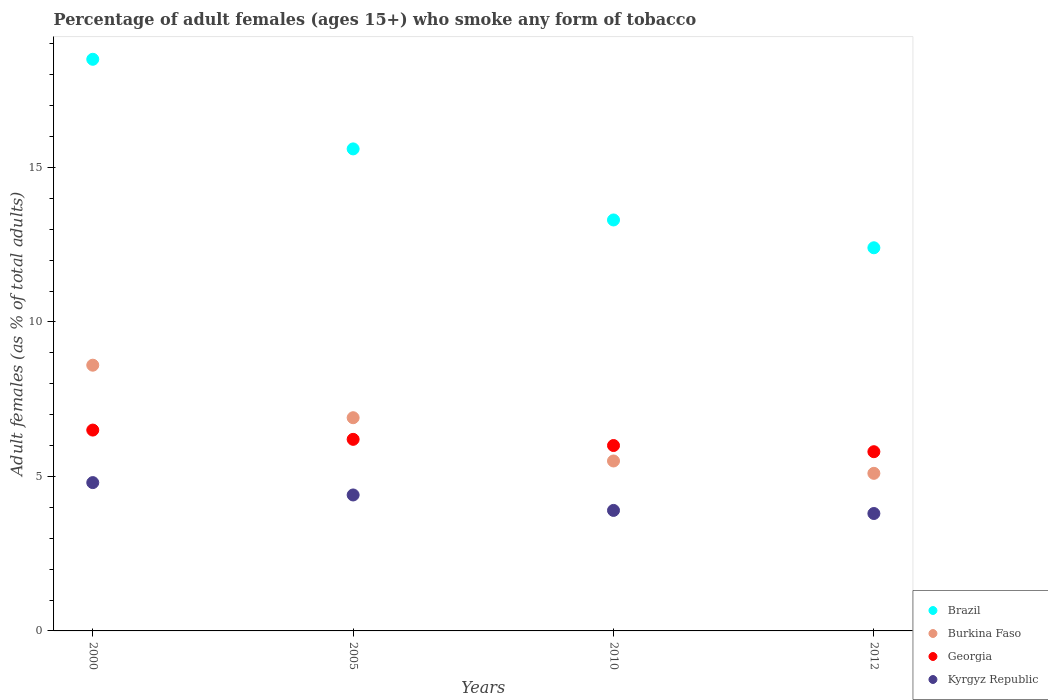Across all years, what is the maximum percentage of adult females who smoke in Kyrgyz Republic?
Make the answer very short. 4.8. Across all years, what is the minimum percentage of adult females who smoke in Georgia?
Your response must be concise. 5.8. In which year was the percentage of adult females who smoke in Kyrgyz Republic maximum?
Your answer should be compact. 2000. What is the total percentage of adult females who smoke in Burkina Faso in the graph?
Your response must be concise. 26.1. What is the difference between the percentage of adult females who smoke in Burkina Faso in 2000 and that in 2012?
Keep it short and to the point. 3.5. What is the difference between the percentage of adult females who smoke in Burkina Faso in 2005 and the percentage of adult females who smoke in Brazil in 2010?
Make the answer very short. -6.4. What is the average percentage of adult females who smoke in Brazil per year?
Provide a succinct answer. 14.95. In the year 2005, what is the difference between the percentage of adult females who smoke in Georgia and percentage of adult females who smoke in Brazil?
Give a very brief answer. -9.4. What is the ratio of the percentage of adult females who smoke in Kyrgyz Republic in 2005 to that in 2010?
Your answer should be very brief. 1.13. Is the difference between the percentage of adult females who smoke in Georgia in 2005 and 2010 greater than the difference between the percentage of adult females who smoke in Brazil in 2005 and 2010?
Provide a short and direct response. No. What is the difference between the highest and the second highest percentage of adult females who smoke in Burkina Faso?
Offer a terse response. 1.7. Is it the case that in every year, the sum of the percentage of adult females who smoke in Kyrgyz Republic and percentage of adult females who smoke in Brazil  is greater than the percentage of adult females who smoke in Burkina Faso?
Offer a terse response. Yes. Does the percentage of adult females who smoke in Brazil monotonically increase over the years?
Provide a short and direct response. No. Is the percentage of adult females who smoke in Brazil strictly less than the percentage of adult females who smoke in Kyrgyz Republic over the years?
Give a very brief answer. No. What is the difference between two consecutive major ticks on the Y-axis?
Make the answer very short. 5. Does the graph contain grids?
Ensure brevity in your answer.  No. Where does the legend appear in the graph?
Your answer should be compact. Bottom right. How many legend labels are there?
Your response must be concise. 4. How are the legend labels stacked?
Give a very brief answer. Vertical. What is the title of the graph?
Your answer should be very brief. Percentage of adult females (ages 15+) who smoke any form of tobacco. What is the label or title of the Y-axis?
Offer a very short reply. Adult females (as % of total adults). What is the Adult females (as % of total adults) in Brazil in 2000?
Make the answer very short. 18.5. What is the Adult females (as % of total adults) of Georgia in 2000?
Keep it short and to the point. 6.5. What is the Adult females (as % of total adults) of Kyrgyz Republic in 2000?
Keep it short and to the point. 4.8. What is the Adult females (as % of total adults) in Burkina Faso in 2005?
Your answer should be compact. 6.9. What is the Adult females (as % of total adults) of Georgia in 2012?
Make the answer very short. 5.8. Across all years, what is the maximum Adult females (as % of total adults) of Brazil?
Keep it short and to the point. 18.5. Across all years, what is the maximum Adult females (as % of total adults) in Burkina Faso?
Offer a very short reply. 8.6. Across all years, what is the maximum Adult females (as % of total adults) in Georgia?
Make the answer very short. 6.5. Across all years, what is the maximum Adult females (as % of total adults) of Kyrgyz Republic?
Keep it short and to the point. 4.8. Across all years, what is the minimum Adult females (as % of total adults) of Burkina Faso?
Make the answer very short. 5.1. Across all years, what is the minimum Adult females (as % of total adults) in Georgia?
Provide a succinct answer. 5.8. Across all years, what is the minimum Adult females (as % of total adults) in Kyrgyz Republic?
Your answer should be compact. 3.8. What is the total Adult females (as % of total adults) of Brazil in the graph?
Ensure brevity in your answer.  59.8. What is the total Adult females (as % of total adults) of Burkina Faso in the graph?
Keep it short and to the point. 26.1. What is the difference between the Adult females (as % of total adults) of Brazil in 2000 and that in 2005?
Give a very brief answer. 2.9. What is the difference between the Adult females (as % of total adults) in Georgia in 2000 and that in 2005?
Make the answer very short. 0.3. What is the difference between the Adult females (as % of total adults) of Brazil in 2000 and that in 2010?
Provide a succinct answer. 5.2. What is the difference between the Adult females (as % of total adults) of Georgia in 2000 and that in 2010?
Your answer should be very brief. 0.5. What is the difference between the Adult females (as % of total adults) in Kyrgyz Republic in 2000 and that in 2010?
Offer a terse response. 0.9. What is the difference between the Adult females (as % of total adults) of Burkina Faso in 2000 and that in 2012?
Make the answer very short. 3.5. What is the difference between the Adult females (as % of total adults) in Kyrgyz Republic in 2000 and that in 2012?
Keep it short and to the point. 1. What is the difference between the Adult females (as % of total adults) of Brazil in 2005 and that in 2010?
Offer a very short reply. 2.3. What is the difference between the Adult females (as % of total adults) of Burkina Faso in 2005 and that in 2010?
Your response must be concise. 1.4. What is the difference between the Adult females (as % of total adults) in Kyrgyz Republic in 2005 and that in 2010?
Provide a succinct answer. 0.5. What is the difference between the Adult females (as % of total adults) of Brazil in 2005 and that in 2012?
Give a very brief answer. 3.2. What is the difference between the Adult females (as % of total adults) in Burkina Faso in 2005 and that in 2012?
Provide a succinct answer. 1.8. What is the difference between the Adult females (as % of total adults) of Kyrgyz Republic in 2005 and that in 2012?
Your answer should be compact. 0.6. What is the difference between the Adult females (as % of total adults) of Burkina Faso in 2010 and that in 2012?
Your response must be concise. 0.4. What is the difference between the Adult females (as % of total adults) of Kyrgyz Republic in 2010 and that in 2012?
Keep it short and to the point. 0.1. What is the difference between the Adult females (as % of total adults) of Brazil in 2000 and the Adult females (as % of total adults) of Kyrgyz Republic in 2005?
Your answer should be compact. 14.1. What is the difference between the Adult females (as % of total adults) of Burkina Faso in 2000 and the Adult females (as % of total adults) of Georgia in 2005?
Offer a very short reply. 2.4. What is the difference between the Adult females (as % of total adults) in Burkina Faso in 2000 and the Adult females (as % of total adults) in Kyrgyz Republic in 2005?
Give a very brief answer. 4.2. What is the difference between the Adult females (as % of total adults) in Georgia in 2000 and the Adult females (as % of total adults) in Kyrgyz Republic in 2005?
Provide a short and direct response. 2.1. What is the difference between the Adult females (as % of total adults) in Brazil in 2000 and the Adult females (as % of total adults) in Georgia in 2010?
Provide a short and direct response. 12.5. What is the difference between the Adult females (as % of total adults) of Burkina Faso in 2000 and the Adult females (as % of total adults) of Georgia in 2010?
Make the answer very short. 2.6. What is the difference between the Adult females (as % of total adults) in Brazil in 2000 and the Adult females (as % of total adults) in Georgia in 2012?
Offer a terse response. 12.7. What is the difference between the Adult females (as % of total adults) of Brazil in 2000 and the Adult females (as % of total adults) of Kyrgyz Republic in 2012?
Your answer should be very brief. 14.7. What is the difference between the Adult females (as % of total adults) of Burkina Faso in 2000 and the Adult females (as % of total adults) of Georgia in 2012?
Keep it short and to the point. 2.8. What is the difference between the Adult females (as % of total adults) in Burkina Faso in 2000 and the Adult females (as % of total adults) in Kyrgyz Republic in 2012?
Ensure brevity in your answer.  4.8. What is the difference between the Adult females (as % of total adults) in Brazil in 2005 and the Adult females (as % of total adults) in Burkina Faso in 2010?
Provide a short and direct response. 10.1. What is the difference between the Adult females (as % of total adults) in Brazil in 2005 and the Adult females (as % of total adults) in Georgia in 2010?
Provide a succinct answer. 9.6. What is the difference between the Adult females (as % of total adults) of Brazil in 2005 and the Adult females (as % of total adults) of Georgia in 2012?
Provide a short and direct response. 9.8. What is the difference between the Adult females (as % of total adults) of Brazil in 2005 and the Adult females (as % of total adults) of Kyrgyz Republic in 2012?
Your answer should be compact. 11.8. What is the difference between the Adult females (as % of total adults) of Burkina Faso in 2005 and the Adult females (as % of total adults) of Kyrgyz Republic in 2012?
Your answer should be very brief. 3.1. What is the difference between the Adult females (as % of total adults) in Georgia in 2005 and the Adult females (as % of total adults) in Kyrgyz Republic in 2012?
Give a very brief answer. 2.4. What is the difference between the Adult females (as % of total adults) in Brazil in 2010 and the Adult females (as % of total adults) in Kyrgyz Republic in 2012?
Ensure brevity in your answer.  9.5. What is the difference between the Adult females (as % of total adults) in Burkina Faso in 2010 and the Adult females (as % of total adults) in Georgia in 2012?
Offer a terse response. -0.3. What is the difference between the Adult females (as % of total adults) in Georgia in 2010 and the Adult females (as % of total adults) in Kyrgyz Republic in 2012?
Your response must be concise. 2.2. What is the average Adult females (as % of total adults) of Brazil per year?
Your answer should be compact. 14.95. What is the average Adult females (as % of total adults) in Burkina Faso per year?
Provide a succinct answer. 6.53. What is the average Adult females (as % of total adults) of Georgia per year?
Ensure brevity in your answer.  6.12. What is the average Adult females (as % of total adults) in Kyrgyz Republic per year?
Provide a succinct answer. 4.22. In the year 2000, what is the difference between the Adult females (as % of total adults) in Brazil and Adult females (as % of total adults) in Georgia?
Offer a terse response. 12. In the year 2000, what is the difference between the Adult females (as % of total adults) of Burkina Faso and Adult females (as % of total adults) of Kyrgyz Republic?
Your answer should be very brief. 3.8. In the year 2000, what is the difference between the Adult females (as % of total adults) of Georgia and Adult females (as % of total adults) of Kyrgyz Republic?
Offer a terse response. 1.7. In the year 2005, what is the difference between the Adult females (as % of total adults) in Burkina Faso and Adult females (as % of total adults) in Georgia?
Offer a very short reply. 0.7. In the year 2005, what is the difference between the Adult females (as % of total adults) in Burkina Faso and Adult females (as % of total adults) in Kyrgyz Republic?
Your answer should be very brief. 2.5. In the year 2005, what is the difference between the Adult females (as % of total adults) in Georgia and Adult females (as % of total adults) in Kyrgyz Republic?
Make the answer very short. 1.8. In the year 2010, what is the difference between the Adult females (as % of total adults) of Brazil and Adult females (as % of total adults) of Burkina Faso?
Make the answer very short. 7.8. In the year 2010, what is the difference between the Adult females (as % of total adults) of Brazil and Adult females (as % of total adults) of Georgia?
Offer a very short reply. 7.3. In the year 2010, what is the difference between the Adult females (as % of total adults) in Burkina Faso and Adult females (as % of total adults) in Georgia?
Make the answer very short. -0.5. In the year 2012, what is the difference between the Adult females (as % of total adults) of Brazil and Adult females (as % of total adults) of Burkina Faso?
Provide a succinct answer. 7.3. In the year 2012, what is the difference between the Adult females (as % of total adults) in Brazil and Adult females (as % of total adults) in Georgia?
Your answer should be very brief. 6.6. In the year 2012, what is the difference between the Adult females (as % of total adults) in Brazil and Adult females (as % of total adults) in Kyrgyz Republic?
Provide a short and direct response. 8.6. In the year 2012, what is the difference between the Adult females (as % of total adults) of Georgia and Adult females (as % of total adults) of Kyrgyz Republic?
Ensure brevity in your answer.  2. What is the ratio of the Adult females (as % of total adults) of Brazil in 2000 to that in 2005?
Offer a very short reply. 1.19. What is the ratio of the Adult females (as % of total adults) in Burkina Faso in 2000 to that in 2005?
Give a very brief answer. 1.25. What is the ratio of the Adult females (as % of total adults) of Georgia in 2000 to that in 2005?
Your response must be concise. 1.05. What is the ratio of the Adult females (as % of total adults) of Brazil in 2000 to that in 2010?
Make the answer very short. 1.39. What is the ratio of the Adult females (as % of total adults) of Burkina Faso in 2000 to that in 2010?
Ensure brevity in your answer.  1.56. What is the ratio of the Adult females (as % of total adults) in Kyrgyz Republic in 2000 to that in 2010?
Your response must be concise. 1.23. What is the ratio of the Adult females (as % of total adults) of Brazil in 2000 to that in 2012?
Provide a succinct answer. 1.49. What is the ratio of the Adult females (as % of total adults) in Burkina Faso in 2000 to that in 2012?
Provide a short and direct response. 1.69. What is the ratio of the Adult females (as % of total adults) in Georgia in 2000 to that in 2012?
Make the answer very short. 1.12. What is the ratio of the Adult females (as % of total adults) of Kyrgyz Republic in 2000 to that in 2012?
Give a very brief answer. 1.26. What is the ratio of the Adult females (as % of total adults) of Brazil in 2005 to that in 2010?
Give a very brief answer. 1.17. What is the ratio of the Adult females (as % of total adults) in Burkina Faso in 2005 to that in 2010?
Give a very brief answer. 1.25. What is the ratio of the Adult females (as % of total adults) in Georgia in 2005 to that in 2010?
Offer a very short reply. 1.03. What is the ratio of the Adult females (as % of total adults) of Kyrgyz Republic in 2005 to that in 2010?
Your answer should be very brief. 1.13. What is the ratio of the Adult females (as % of total adults) in Brazil in 2005 to that in 2012?
Your answer should be very brief. 1.26. What is the ratio of the Adult females (as % of total adults) of Burkina Faso in 2005 to that in 2012?
Offer a very short reply. 1.35. What is the ratio of the Adult females (as % of total adults) of Georgia in 2005 to that in 2012?
Keep it short and to the point. 1.07. What is the ratio of the Adult females (as % of total adults) in Kyrgyz Republic in 2005 to that in 2012?
Provide a short and direct response. 1.16. What is the ratio of the Adult females (as % of total adults) of Brazil in 2010 to that in 2012?
Offer a very short reply. 1.07. What is the ratio of the Adult females (as % of total adults) in Burkina Faso in 2010 to that in 2012?
Your response must be concise. 1.08. What is the ratio of the Adult females (as % of total adults) of Georgia in 2010 to that in 2012?
Make the answer very short. 1.03. What is the ratio of the Adult females (as % of total adults) of Kyrgyz Republic in 2010 to that in 2012?
Your answer should be very brief. 1.03. What is the difference between the highest and the second highest Adult females (as % of total adults) in Brazil?
Your answer should be very brief. 2.9. What is the difference between the highest and the second highest Adult females (as % of total adults) in Georgia?
Ensure brevity in your answer.  0.3. What is the difference between the highest and the lowest Adult females (as % of total adults) of Brazil?
Ensure brevity in your answer.  6.1. What is the difference between the highest and the lowest Adult females (as % of total adults) in Burkina Faso?
Offer a very short reply. 3.5. 